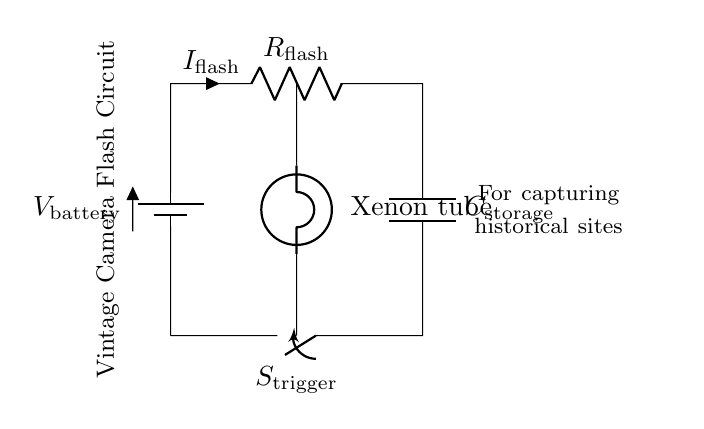What is the type of the primary power source in this circuit? The primary power source is a battery, as indicated by the symbol used in the circuit diagram.
Answer: battery Which component is responsible for storing energy in this circuit? The component responsible for storing energy is the capacitor, which is labeled as C storage in the circuit.
Answer: capacitor What is the current flowing through the flash component? The current flowing through the flash component is indicated by the label I flash in the circuit schematic.
Answer: I flash What role does the switch play in this circuit? The switch, labeled as S trigger in the circuit, controls the connection between the battery and the rest of the circuit components, allowing or stopping the flow of current.
Answer: control current What happens when the trigger switch is closed? When the trigger switch is closed, it completes the circuit, allowing current to flow from the battery through the resistor and capacitor to the xenon tube, resulting in flash activation.
Answer: activates flash Which component generates light in the circuit? The component that generates light in this circuit is the xenon tube, which produces a flash of light when energized.
Answer: xenon tube 